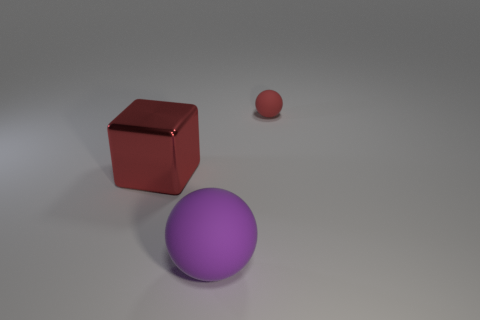Are there any other things that are made of the same material as the large red object?
Offer a very short reply. No. Does the cube have the same color as the object right of the purple ball?
Provide a short and direct response. Yes. How many red things are tiny objects or metallic cubes?
Provide a short and direct response. 2. What shape is the metal object?
Give a very brief answer. Cube. How many other objects are the same shape as the large red metal object?
Ensure brevity in your answer.  0. The thing that is in front of the red block is what color?
Offer a very short reply. Purple. Do the purple thing and the block have the same material?
Keep it short and to the point. No. How many things are purple objects or objects that are behind the purple thing?
Provide a succinct answer. 3. There is a metal block that is the same color as the small sphere; what size is it?
Ensure brevity in your answer.  Large. There is a rubber thing that is behind the large matte sphere; what shape is it?
Provide a short and direct response. Sphere. 